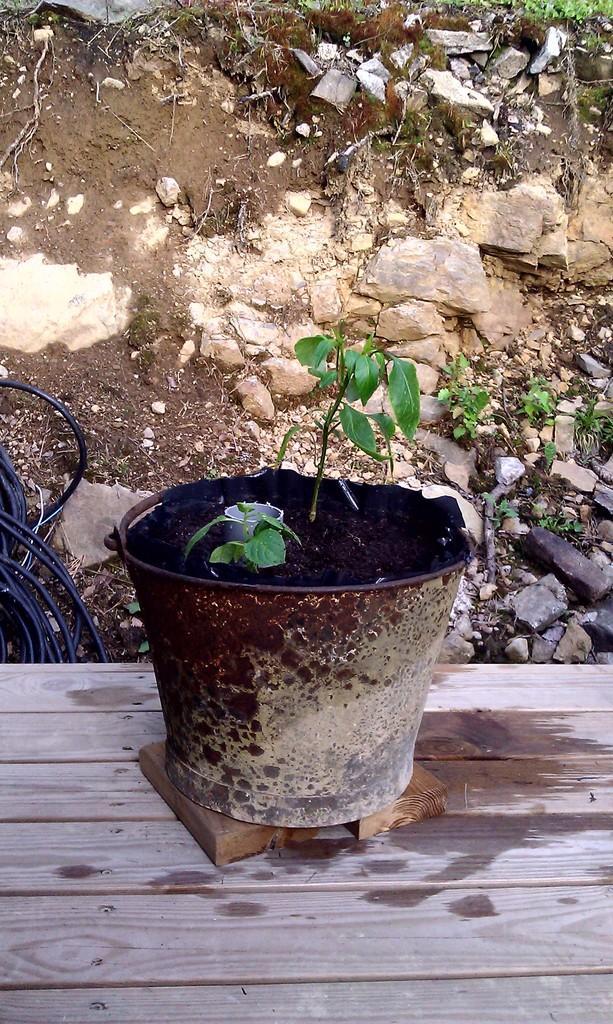How would you summarize this image in a sentence or two? In this picture there is a plant in the foreground. At the back there are wires and there are stones and there is grass. At the bottom there is a wooden object. 